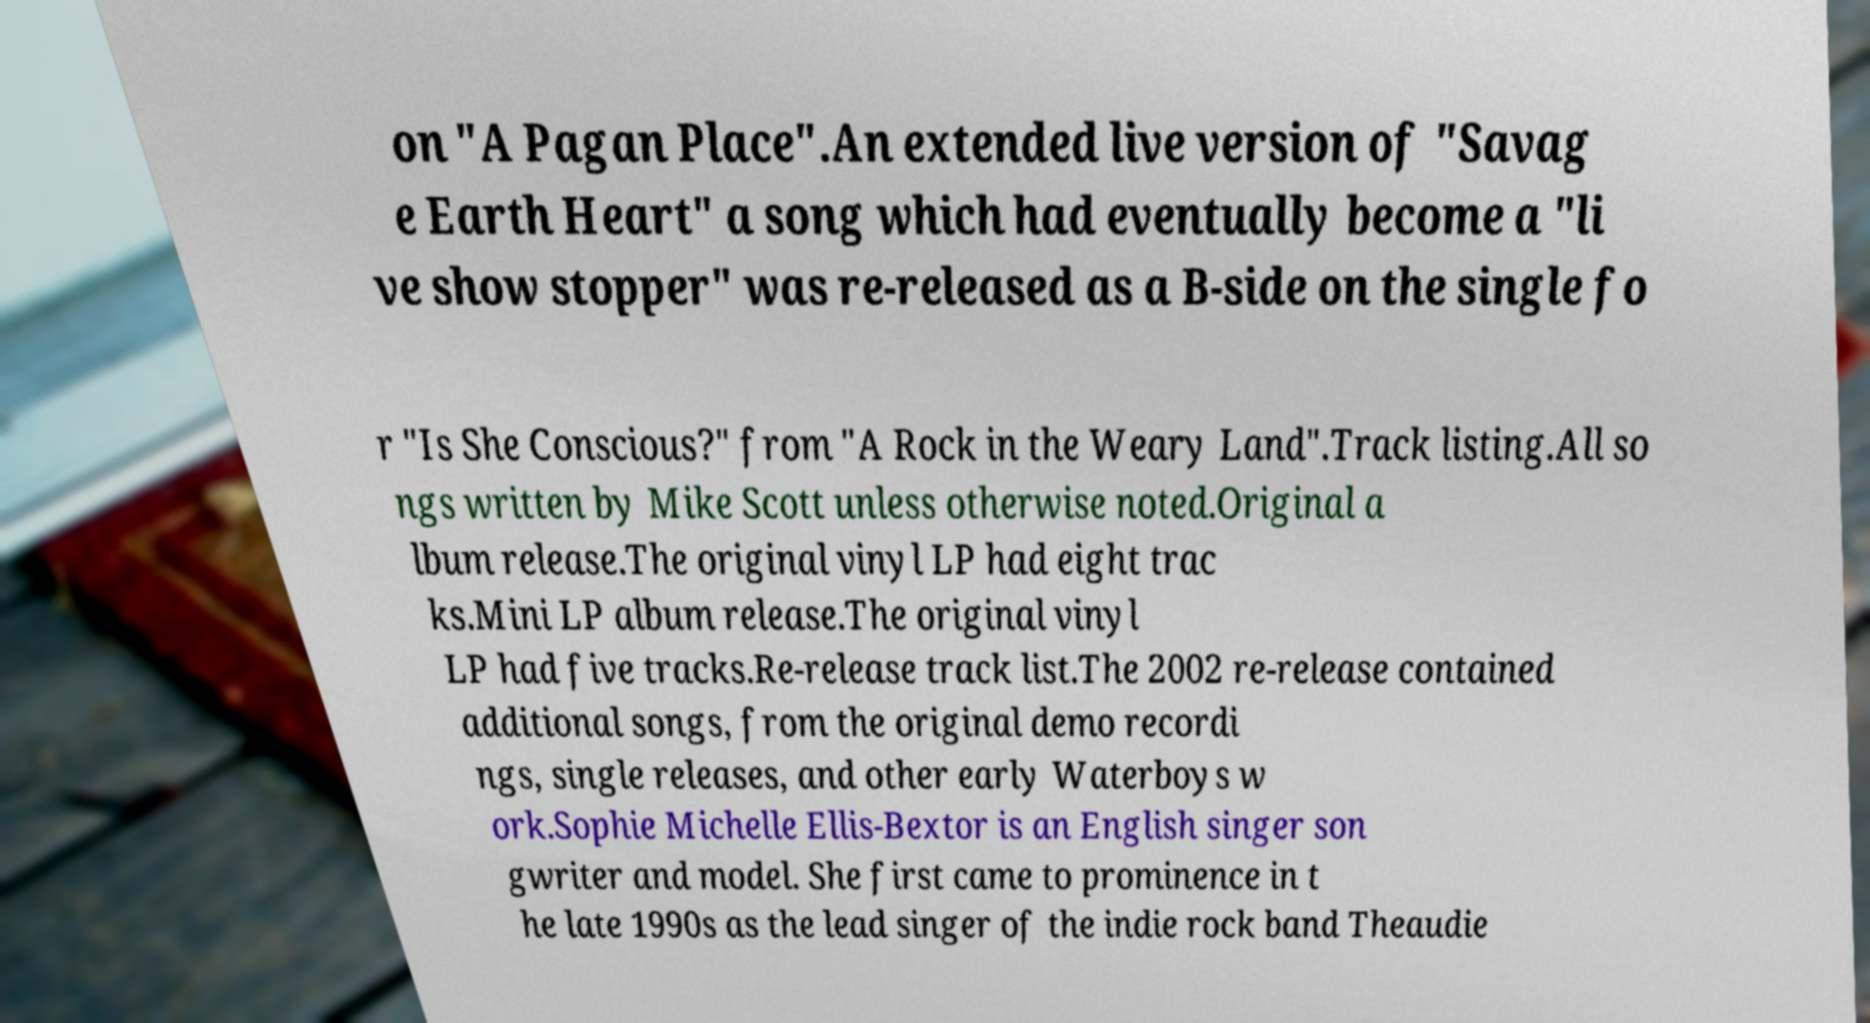There's text embedded in this image that I need extracted. Can you transcribe it verbatim? on "A Pagan Place".An extended live version of "Savag e Earth Heart" a song which had eventually become a "li ve show stopper" was re-released as a B-side on the single fo r "Is She Conscious?" from "A Rock in the Weary Land".Track listing.All so ngs written by Mike Scott unless otherwise noted.Original a lbum release.The original vinyl LP had eight trac ks.Mini LP album release.The original vinyl LP had five tracks.Re-release track list.The 2002 re-release contained additional songs, from the original demo recordi ngs, single releases, and other early Waterboys w ork.Sophie Michelle Ellis-Bextor is an English singer son gwriter and model. She first came to prominence in t he late 1990s as the lead singer of the indie rock band Theaudie 